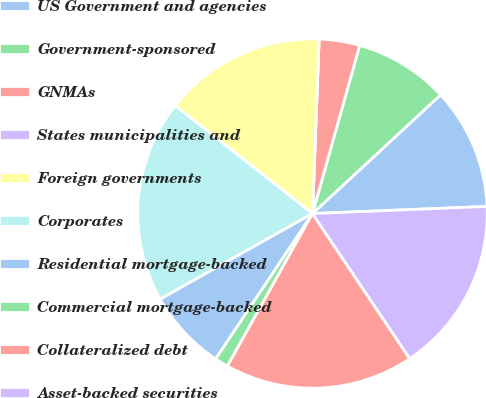Convert chart to OTSL. <chart><loc_0><loc_0><loc_500><loc_500><pie_chart><fcel>US Government and agencies<fcel>Government-sponsored<fcel>GNMAs<fcel>States municipalities and<fcel>Foreign governments<fcel>Corporates<fcel>Residential mortgage-backed<fcel>Commercial mortgage-backed<fcel>Collateralized debt<fcel>Asset-backed securities<nl><fcel>11.25%<fcel>8.75%<fcel>3.75%<fcel>0.0%<fcel>15.0%<fcel>18.75%<fcel>7.5%<fcel>1.25%<fcel>17.5%<fcel>16.25%<nl></chart> 